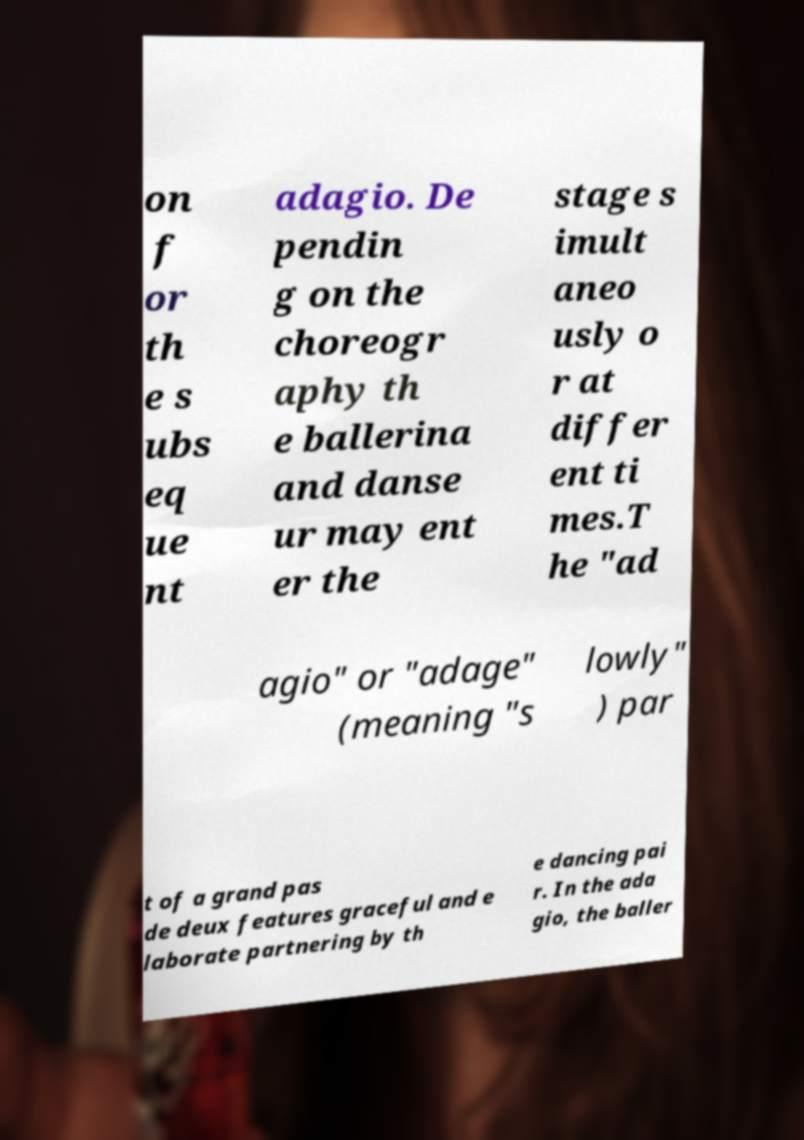Please read and relay the text visible in this image. What does it say? on f or th e s ubs eq ue nt adagio. De pendin g on the choreogr aphy th e ballerina and danse ur may ent er the stage s imult aneo usly o r at differ ent ti mes.T he "ad agio" or "adage" (meaning "s lowly" ) par t of a grand pas de deux features graceful and e laborate partnering by th e dancing pai r. In the ada gio, the baller 